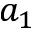Convert formula to latex. <formula><loc_0><loc_0><loc_500><loc_500>a _ { 1 }</formula> 